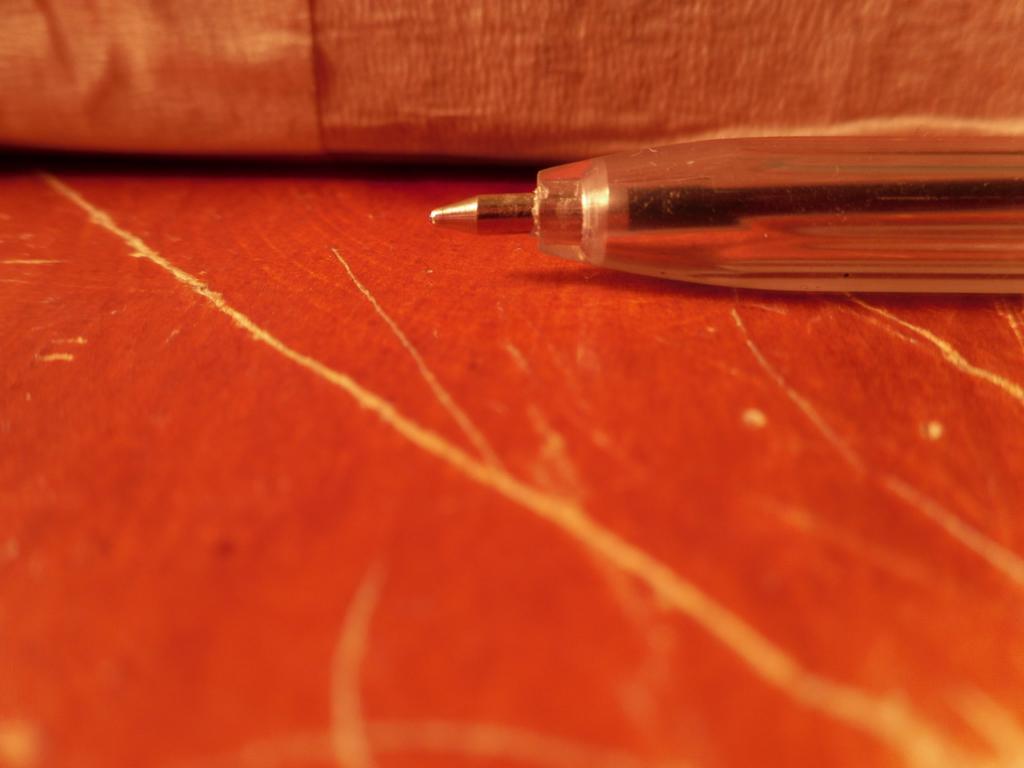Please provide a concise description of this image. On the right there is a pen. At the bottom it is a wooden object. At the there is an object. 